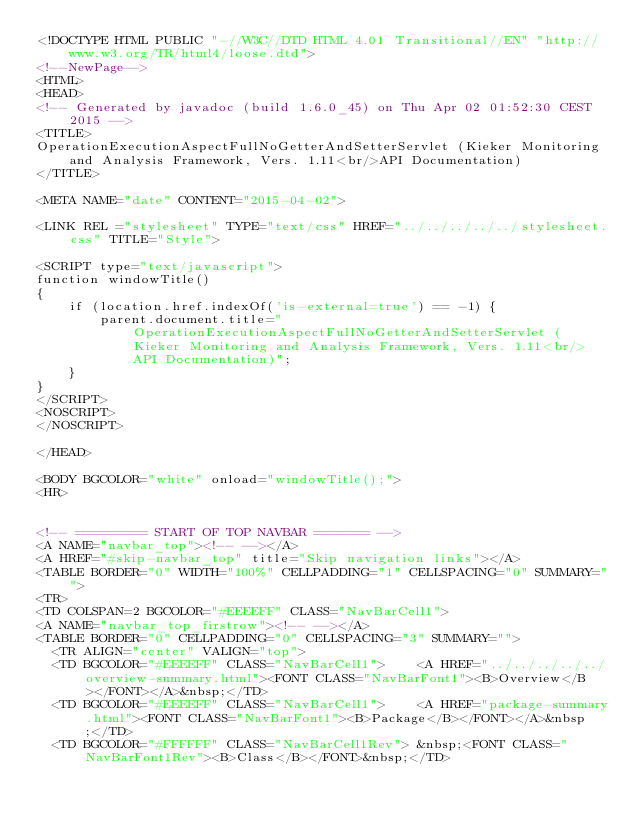Convert code to text. <code><loc_0><loc_0><loc_500><loc_500><_HTML_><!DOCTYPE HTML PUBLIC "-//W3C//DTD HTML 4.01 Transitional//EN" "http://www.w3.org/TR/html4/loose.dtd">
<!--NewPage-->
<HTML>
<HEAD>
<!-- Generated by javadoc (build 1.6.0_45) on Thu Apr 02 01:52:30 CEST 2015 -->
<TITLE>
OperationExecutionAspectFullNoGetterAndSetterServlet (Kieker Monitoring and Analysis Framework, Vers. 1.11<br/>API Documentation)
</TITLE>

<META NAME="date" CONTENT="2015-04-02">

<LINK REL ="stylesheet" TYPE="text/css" HREF="../../../../../stylesheet.css" TITLE="Style">

<SCRIPT type="text/javascript">
function windowTitle()
{
    if (location.href.indexOf('is-external=true') == -1) {
        parent.document.title="OperationExecutionAspectFullNoGetterAndSetterServlet (Kieker Monitoring and Analysis Framework, Vers. 1.11<br/>API Documentation)";
    }
}
</SCRIPT>
<NOSCRIPT>
</NOSCRIPT>

</HEAD>

<BODY BGCOLOR="white" onload="windowTitle();">
<HR>


<!-- ========= START OF TOP NAVBAR ======= -->
<A NAME="navbar_top"><!-- --></A>
<A HREF="#skip-navbar_top" title="Skip navigation links"></A>
<TABLE BORDER="0" WIDTH="100%" CELLPADDING="1" CELLSPACING="0" SUMMARY="">
<TR>
<TD COLSPAN=2 BGCOLOR="#EEEEFF" CLASS="NavBarCell1">
<A NAME="navbar_top_firstrow"><!-- --></A>
<TABLE BORDER="0" CELLPADDING="0" CELLSPACING="3" SUMMARY="">
  <TR ALIGN="center" VALIGN="top">
  <TD BGCOLOR="#EEEEFF" CLASS="NavBarCell1">    <A HREF="../../../../../overview-summary.html"><FONT CLASS="NavBarFont1"><B>Overview</B></FONT></A>&nbsp;</TD>
  <TD BGCOLOR="#EEEEFF" CLASS="NavBarCell1">    <A HREF="package-summary.html"><FONT CLASS="NavBarFont1"><B>Package</B></FONT></A>&nbsp;</TD>
  <TD BGCOLOR="#FFFFFF" CLASS="NavBarCell1Rev"> &nbsp;<FONT CLASS="NavBarFont1Rev"><B>Class</B></FONT>&nbsp;</TD></code> 